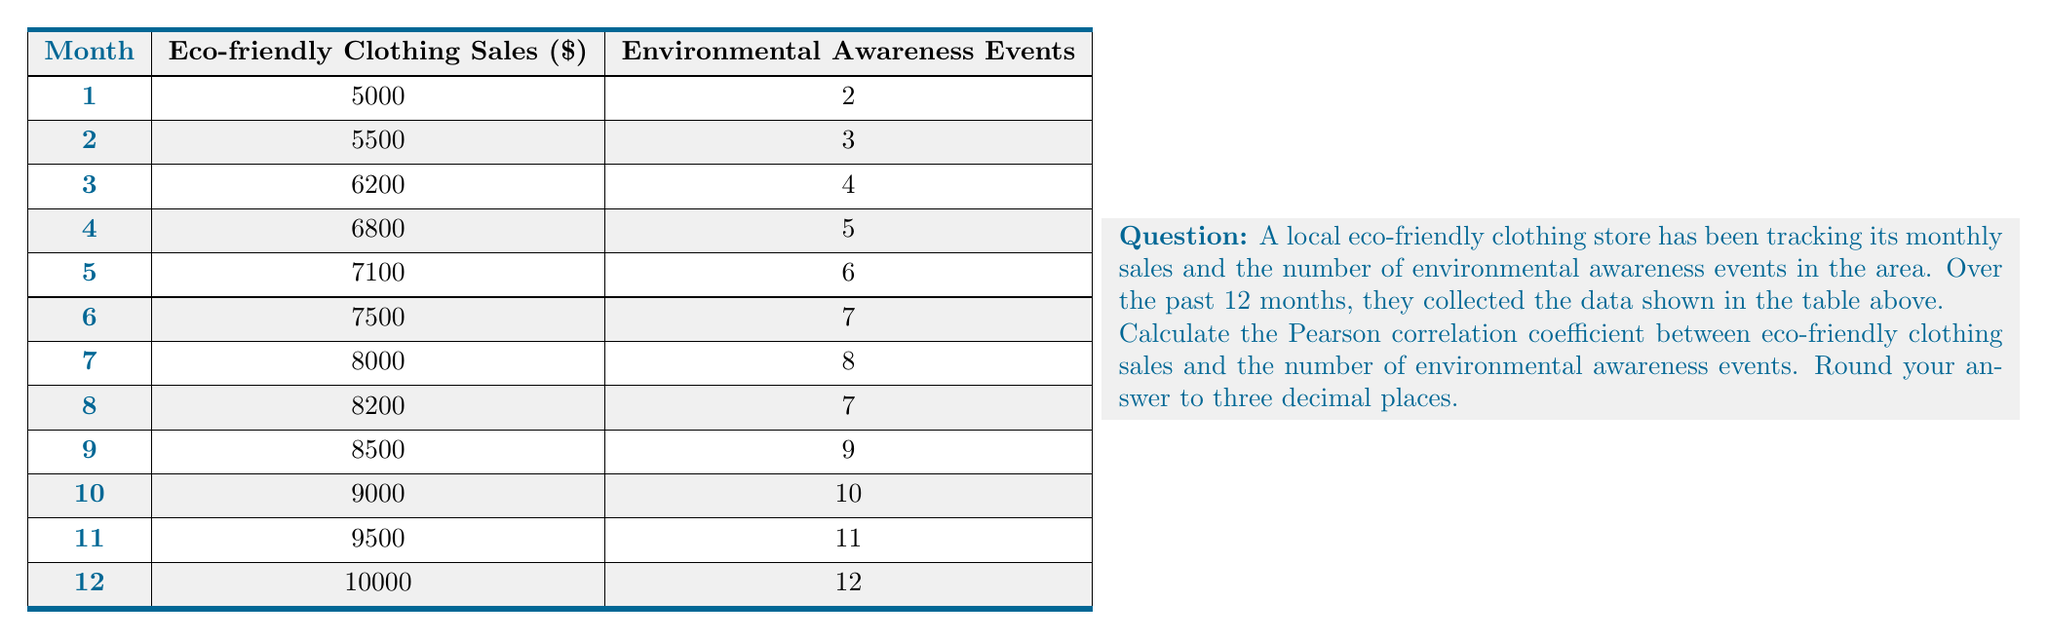Could you help me with this problem? To calculate the Pearson correlation coefficient, we'll use the formula:

$$ r = \frac{n\sum xy - (\sum x)(\sum y)}{\sqrt{[n\sum x^2 - (\sum x)^2][n\sum y^2 - (\sum y)^2]}} $$

Where:
$x$ = Eco-friendly Clothing Sales
$y$ = Environmental Awareness Events
$n$ = Number of data points (12 months)

Step 1: Calculate the sums and squared sums:
$\sum x = 91300$
$\sum y = 84$
$\sum xy = 662900$
$\sum x^2 = 701290000$
$\sum y^2 = 650$

Step 2: Calculate $(\sum x)^2$ and $(\sum y)^2$:
$(\sum x)^2 = 8335690000$
$(\sum y)^2 = 7056$

Step 3: Substitute values into the formula:

$$ r = \frac{12(662900) - (91300)(84)}{\sqrt{[12(701290000) - 8335690000][12(650) - 7056]}} $$

Step 4: Simplify:

$$ r = \frac{7954800 - 7669200}{\sqrt{(380190000)(740)}} $$

$$ r = \frac{285600}{\sqrt{281340600000}} $$

$$ r = \frac{285600}{530415.78} $$

$$ r \approx 0.5385 $$

Step 5: Round to three decimal places:

$r \approx 0.539$
Answer: 0.539 